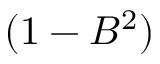Convert formula to latex. <formula><loc_0><loc_0><loc_500><loc_500>( 1 - B ^ { 2 } )</formula> 